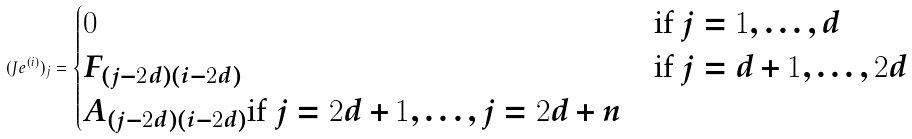<formula> <loc_0><loc_0><loc_500><loc_500>( J e ^ { ( i ) } ) _ { j } = \begin{cases} 0 & \text {if $j=1, \dots, d$} \\ F _ { ( j - 2 d ) ( i - 2 d ) } & \text {if $j=d+1, \dots, 2d$} \\ A _ { ( j - 2 d ) ( i - 2 d ) } \text {if $j=2d+1, \dots, j=2d+n $} \end{cases}</formula> 